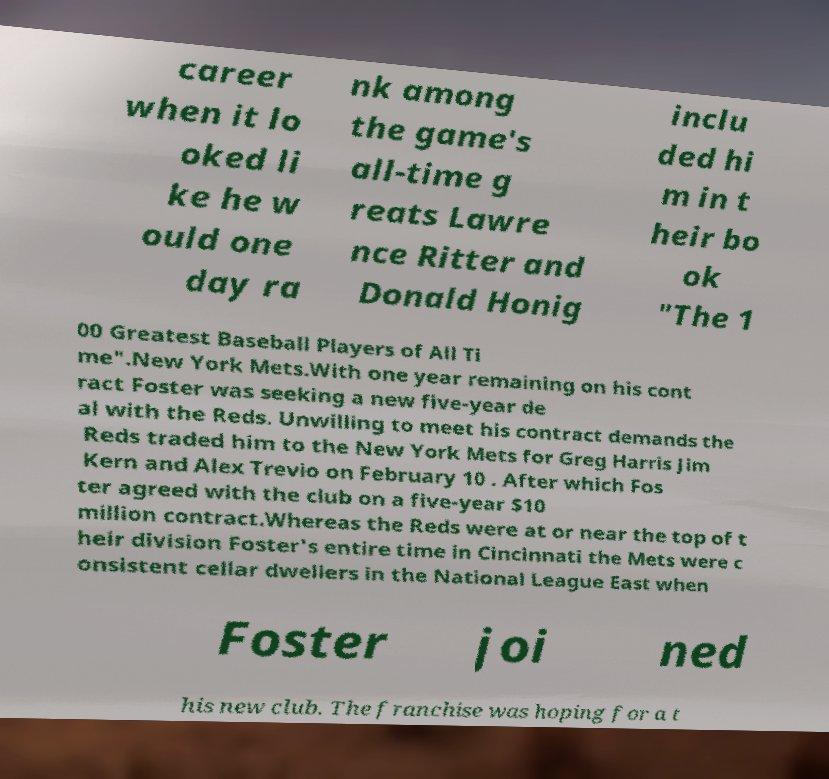I need the written content from this picture converted into text. Can you do that? career when it lo oked li ke he w ould one day ra nk among the game's all-time g reats Lawre nce Ritter and Donald Honig inclu ded hi m in t heir bo ok "The 1 00 Greatest Baseball Players of All Ti me".New York Mets.With one year remaining on his cont ract Foster was seeking a new five-year de al with the Reds. Unwilling to meet his contract demands the Reds traded him to the New York Mets for Greg Harris Jim Kern and Alex Trevio on February 10 . After which Fos ter agreed with the club on a five-year $10 million contract.Whereas the Reds were at or near the top of t heir division Foster's entire time in Cincinnati the Mets were c onsistent cellar dwellers in the National League East when Foster joi ned his new club. The franchise was hoping for a t 